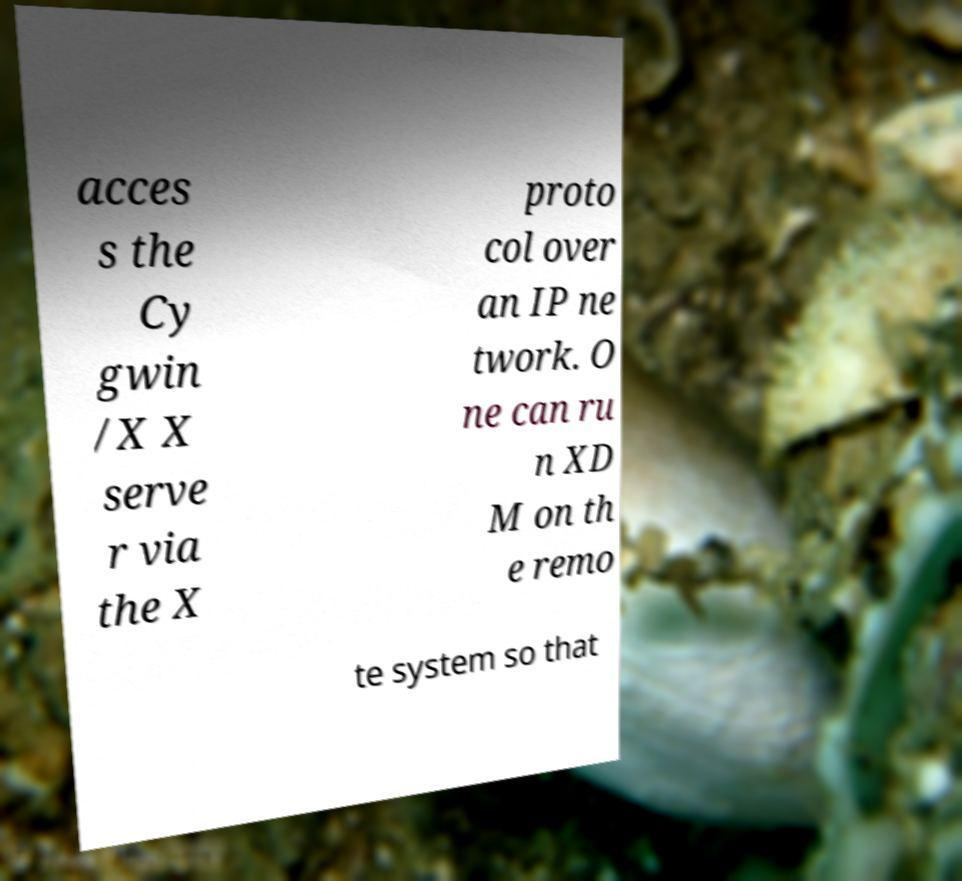Please read and relay the text visible in this image. What does it say? acces s the Cy gwin /X X serve r via the X proto col over an IP ne twork. O ne can ru n XD M on th e remo te system so that 